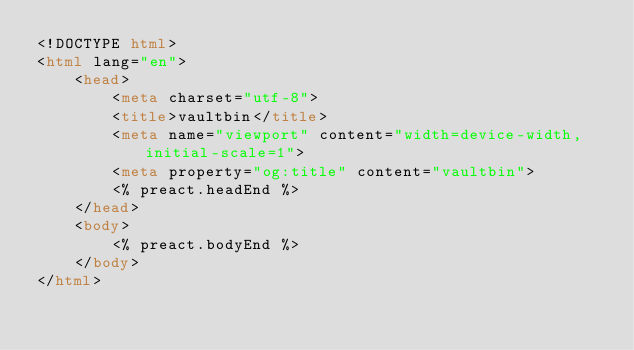Convert code to text. <code><loc_0><loc_0><loc_500><loc_500><_HTML_><!DOCTYPE html>
<html lang="en">
	<head>
		<meta charset="utf-8">
		<title>vaultbin</title>
		<meta name="viewport" content="width=device-width,initial-scale=1">
		<meta property="og:title" content="vaultbin">
		<% preact.headEnd %>
	</head>
	<body>
		<% preact.bodyEnd %>
	</body>
</html>
</code> 